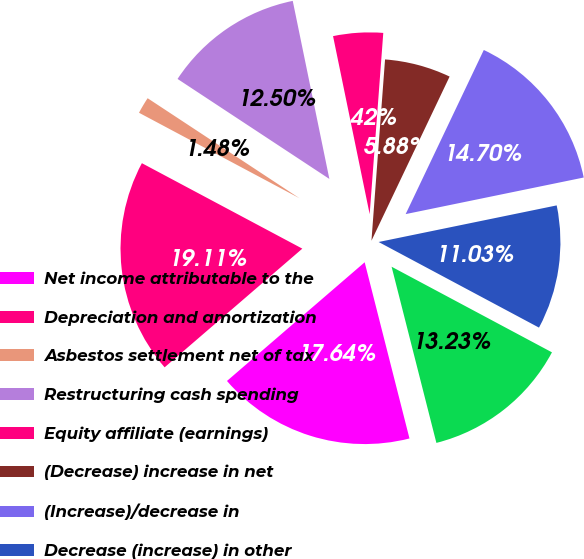Convert chart to OTSL. <chart><loc_0><loc_0><loc_500><loc_500><pie_chart><fcel>Net income attributable to the<fcel>Depreciation and amortization<fcel>Asbestos settlement net of tax<fcel>Restructuring cash spending<fcel>Equity affiliate (earnings)<fcel>(Decrease) increase in net<fcel>(Increase)/decrease in<fcel>Decrease (increase) in other<fcel>Increase/(decrease) in<nl><fcel>17.64%<fcel>19.11%<fcel>1.48%<fcel>12.5%<fcel>4.42%<fcel>5.88%<fcel>14.7%<fcel>11.03%<fcel>13.23%<nl></chart> 